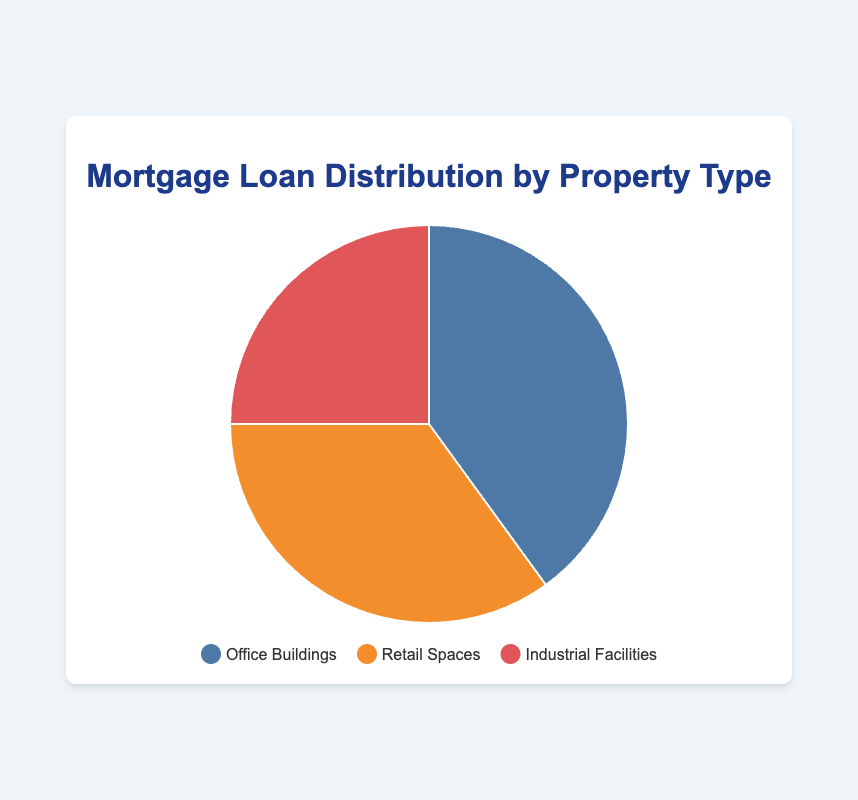Which property type has the highest mortgage loan distribution? By observing the pie chart, the largest segment represents Office Buildings.
Answer: Office Buildings What is the total percentage of mortgage loans for Retail Spaces and Industrial Facilities? Add the percentages for Retail Spaces and Industrial Facilities: 35% + 25%.
Answer: 60% By how much does the mortgage loan distribution for Office Buildings exceed that of Industrial Facilities? Subtract the percentage of Industrial Facilities from Office Buildings: 40% - 25%.
Answer: 15% Which property type is represented by the orange segment? The pie chart legend indicates that the orange segment corresponds to Retail Spaces.
Answer: Retail Spaces Is the percentage of mortgage loans for Retail Spaces greater than that for Industrial Facilities? Compare the percentages: Retail Spaces (35%) is greater than Industrial Facilities (25%).
Answer: Yes What is the average percentage of mortgage loans distributed among the three property types? Sum the three percentages and divide by 3: (40% + 35% + 25%) / 3.
Answer: 33.33% Which two property types together make up exactly two-thirds of the mortgage loan distribution? Two-thirds of the distribution is approximately 66.67%. Adding Office Buildings (40%) and Retail Spaces (35%) gives 75%, while adding Retail Spaces (35%) and Industrial Facilities (25%) gives 60%. Thus, Office Buildings and Industrial Facilities together make up 65%, which is closest to two-thirds.
Answer: Office Buildings and Industrial Facilities What is the difference in mortgage loan distribution percentages between the largest and smallest property types? Subtract the smallest percentage from the largest percentage: 40% (Office Buildings) - 25% (Industrial Facilities).
Answer: 15% What color represents the segment for Industrial Facilities? Referring to the legend, the color representing Industrial Facilities is a shade of red.
Answer: Red 